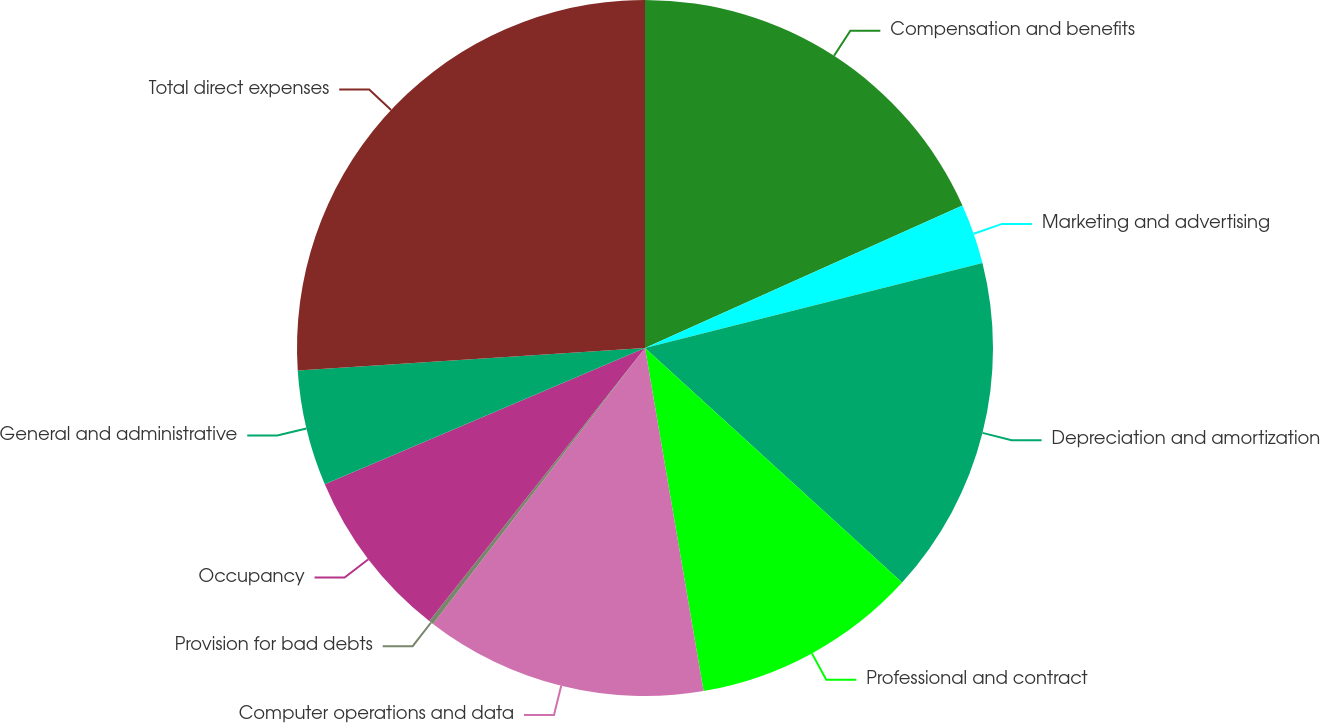Convert chart. <chart><loc_0><loc_0><loc_500><loc_500><pie_chart><fcel>Compensation and benefits<fcel>Marketing and advertising<fcel>Depreciation and amortization<fcel>Professional and contract<fcel>Computer operations and data<fcel>Provision for bad debts<fcel>Occupancy<fcel>General and administrative<fcel>Total direct expenses<nl><fcel>18.28%<fcel>2.79%<fcel>15.7%<fcel>10.54%<fcel>13.12%<fcel>0.21%<fcel>7.96%<fcel>5.37%<fcel>26.03%<nl></chart> 